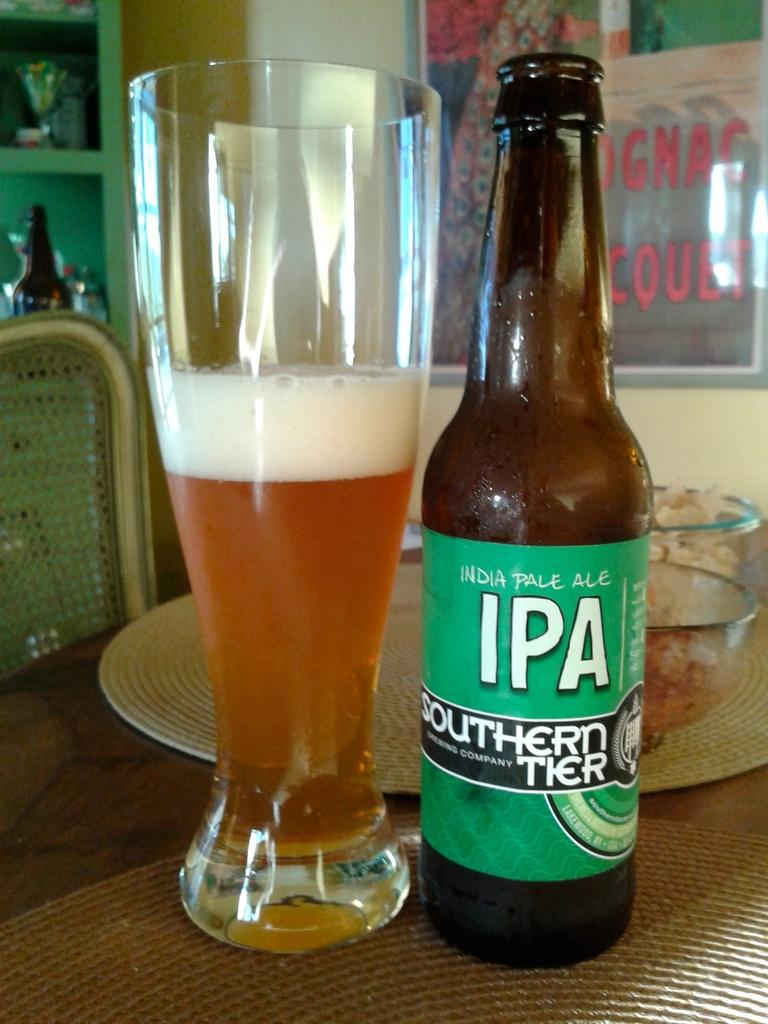<image>
Offer a succinct explanation of the picture presented. A glass that is half full of beer and is next to a beer bottle with the label that says IPA Southern Tier 